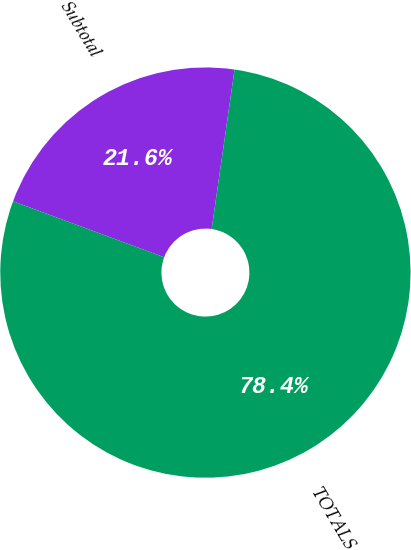Convert chart. <chart><loc_0><loc_0><loc_500><loc_500><pie_chart><fcel>Subtotal<fcel>TOTALS<nl><fcel>21.62%<fcel>78.38%<nl></chart> 